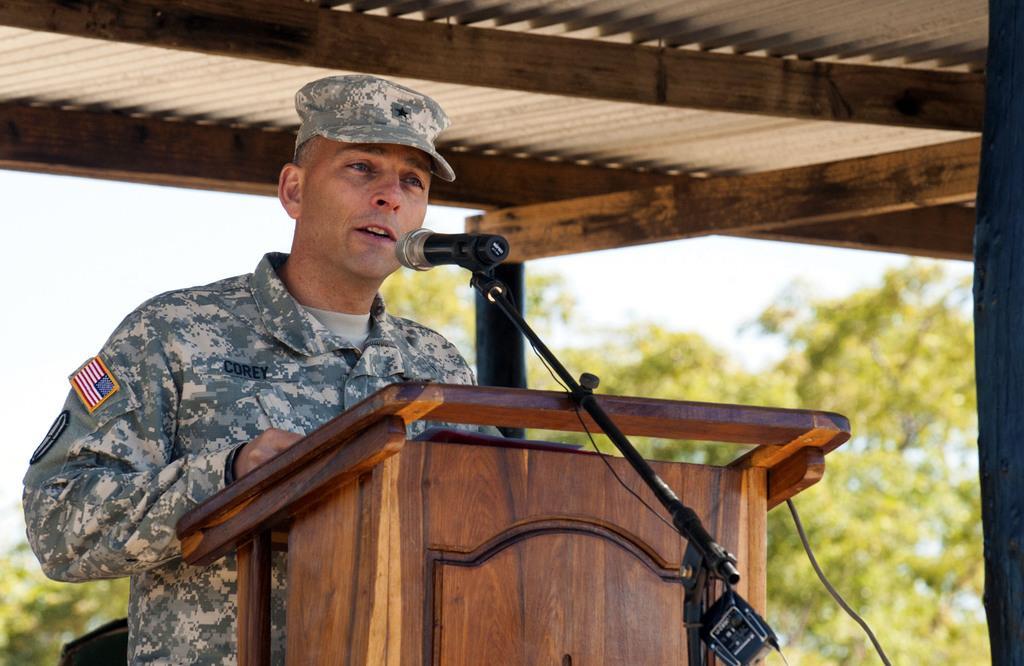Describe this image in one or two sentences. In this picture I can see a man standing at a podium and speaking with help of a microphone and he wore a cap on his head and I can see trees in the back and a cloudy sky. 